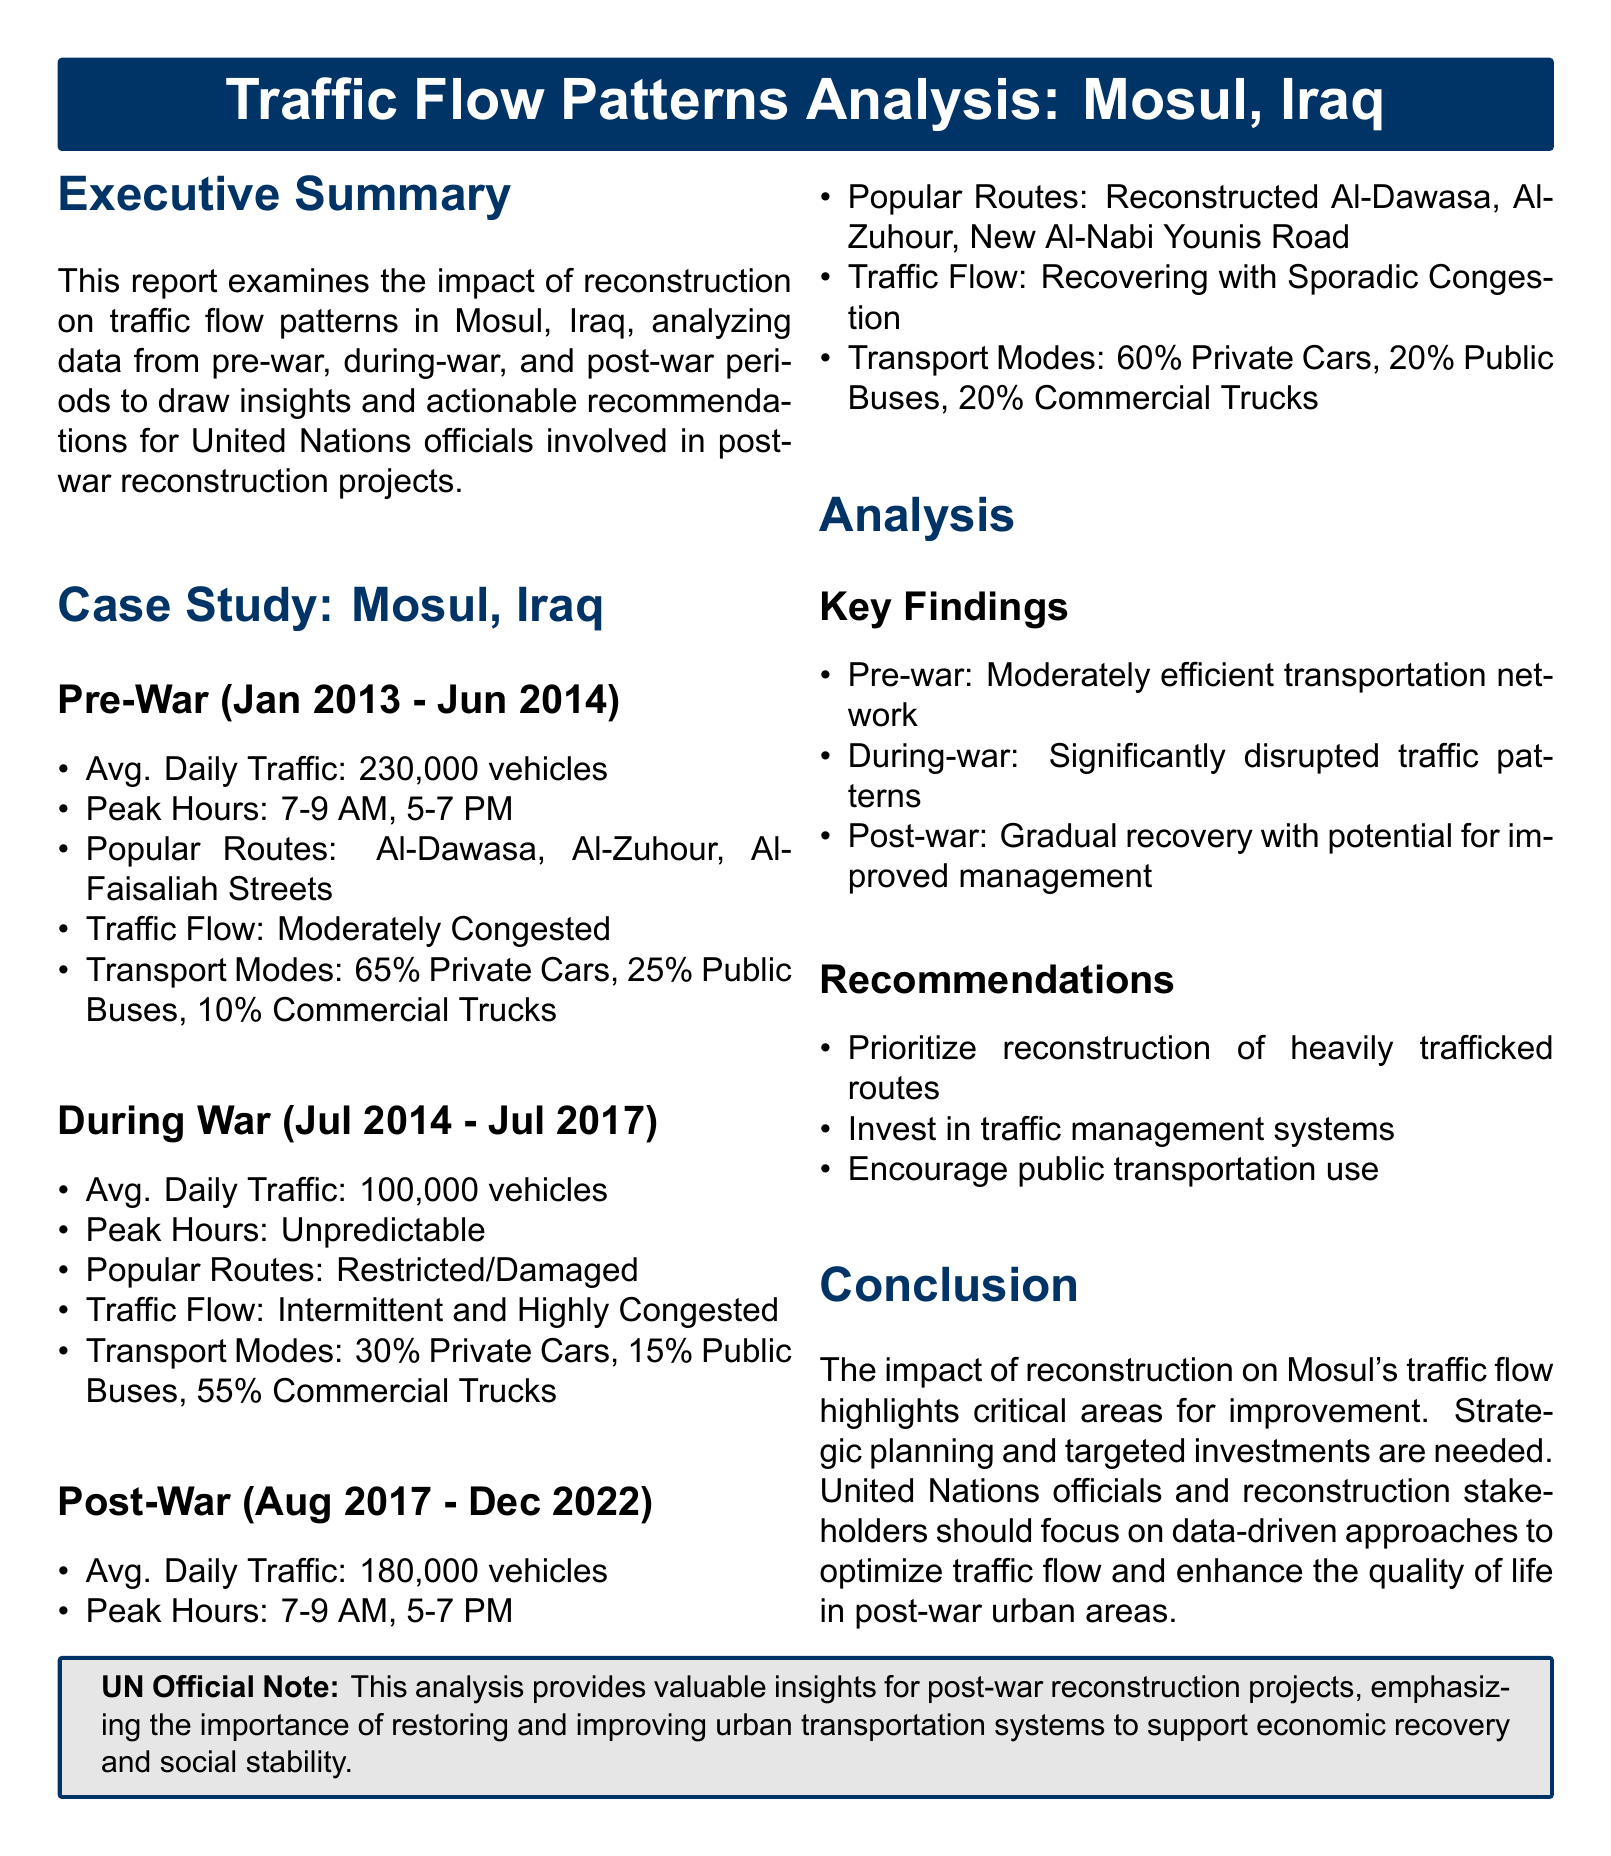What was the average daily traffic during the pre-war period? The average daily traffic during the pre-war period is specifically mentioned in the document.
Answer: 230,000 vehicles What were the popular routes during the post-war period? The document lists the popular routes for the post-war period, highlighting the reconstructed areas.
Answer: Reconstructed Al-Dawasa, Al-Zuhour, New Al-Nabi Younis Road What type of traffic flow was observed during the war? The document describes the traffic flow type during the war, focusing on its status during that time.
Answer: Intermittent and Highly Congested What is the percentage of public buses in the post-war transport modes? This data point is specified in the transport modes section for the post-war period.
Answer: 20% What recommendation was made regarding public transportation? The document offers various recommendations, one of which pertains to public transport.
Answer: Encourage public transportation use How many vehicles characterized the average daily traffic during the war? The data for average daily traffic during the war is clearly stated in the document.
Answer: 100,000 vehicles What peak hours were noted for traffic in the pre-war period? The document outlines the peak hours for the pre-war traffic situation.
Answer: 7-9 AM, 5-7 PM What is the overall conclusion regarding reconstruction's impact on traffic flow? The conclusion summarizes the findings regarding the effects of reconstruction on traffic.
Answer: Strategic planning and targeted investments are needed 